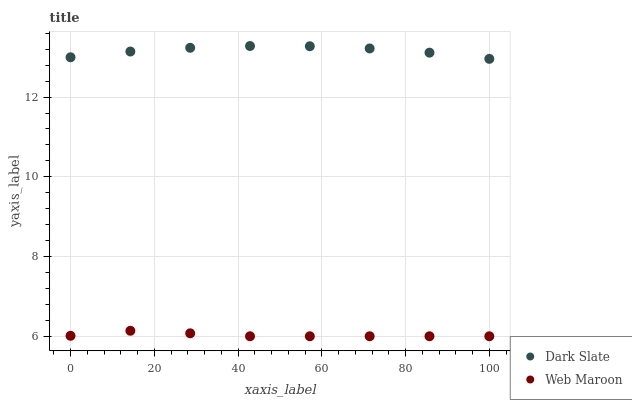Does Web Maroon have the minimum area under the curve?
Answer yes or no. Yes. Does Dark Slate have the maximum area under the curve?
Answer yes or no. Yes. Does Web Maroon have the maximum area under the curve?
Answer yes or no. No. Is Web Maroon the smoothest?
Answer yes or no. Yes. Is Dark Slate the roughest?
Answer yes or no. Yes. Is Web Maroon the roughest?
Answer yes or no. No. Does Web Maroon have the lowest value?
Answer yes or no. Yes. Does Dark Slate have the highest value?
Answer yes or no. Yes. Does Web Maroon have the highest value?
Answer yes or no. No. Is Web Maroon less than Dark Slate?
Answer yes or no. Yes. Is Dark Slate greater than Web Maroon?
Answer yes or no. Yes. Does Web Maroon intersect Dark Slate?
Answer yes or no. No. 